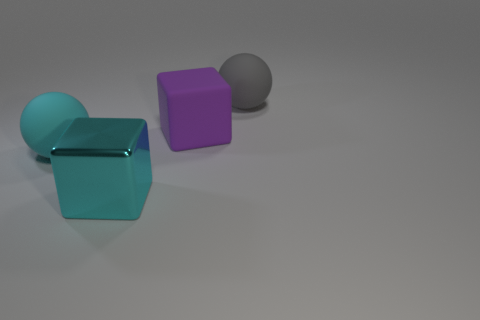Add 2 cyan metallic cubes. How many objects exist? 6 Subtract 0 green cylinders. How many objects are left? 4 Subtract all large blue shiny cylinders. Subtract all purple rubber cubes. How many objects are left? 3 Add 4 cyan rubber things. How many cyan rubber things are left? 5 Add 2 big things. How many big things exist? 6 